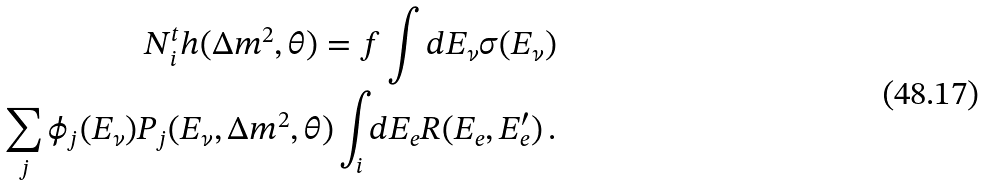Convert formula to latex. <formula><loc_0><loc_0><loc_500><loc_500>N _ { i } ^ { t } h ( \Delta m ^ { 2 } , \theta ) = f \int d E _ { \nu } \sigma ( E _ { \nu } ) \\ \sum _ { j } \phi _ { j } ( E _ { \nu } ) P _ { j } ( E _ { \nu } , \Delta m ^ { 2 } , \theta ) \int _ { i } d E _ { e } R ( E _ { e } , E ^ { \prime } _ { e } ) \, .</formula> 